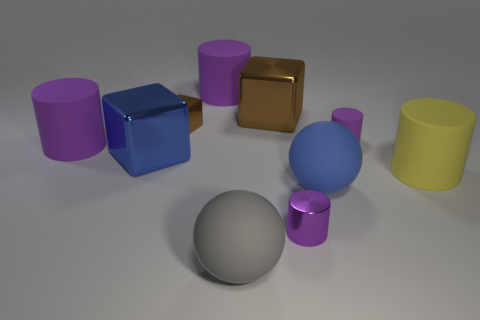Subtract all purple cylinders. How many were subtracted if there are2purple cylinders left? 2 Subtract all cyan blocks. How many purple cylinders are left? 4 Subtract all yellow cylinders. How many cylinders are left? 4 Subtract all small metallic cylinders. How many cylinders are left? 4 Subtract all cyan cylinders. Subtract all blue spheres. How many cylinders are left? 5 Subtract all cubes. How many objects are left? 7 Add 1 purple rubber objects. How many purple rubber objects are left? 4 Add 3 blue rubber objects. How many blue rubber objects exist? 4 Subtract 0 green cylinders. How many objects are left? 10 Subtract all large green cylinders. Subtract all metallic blocks. How many objects are left? 7 